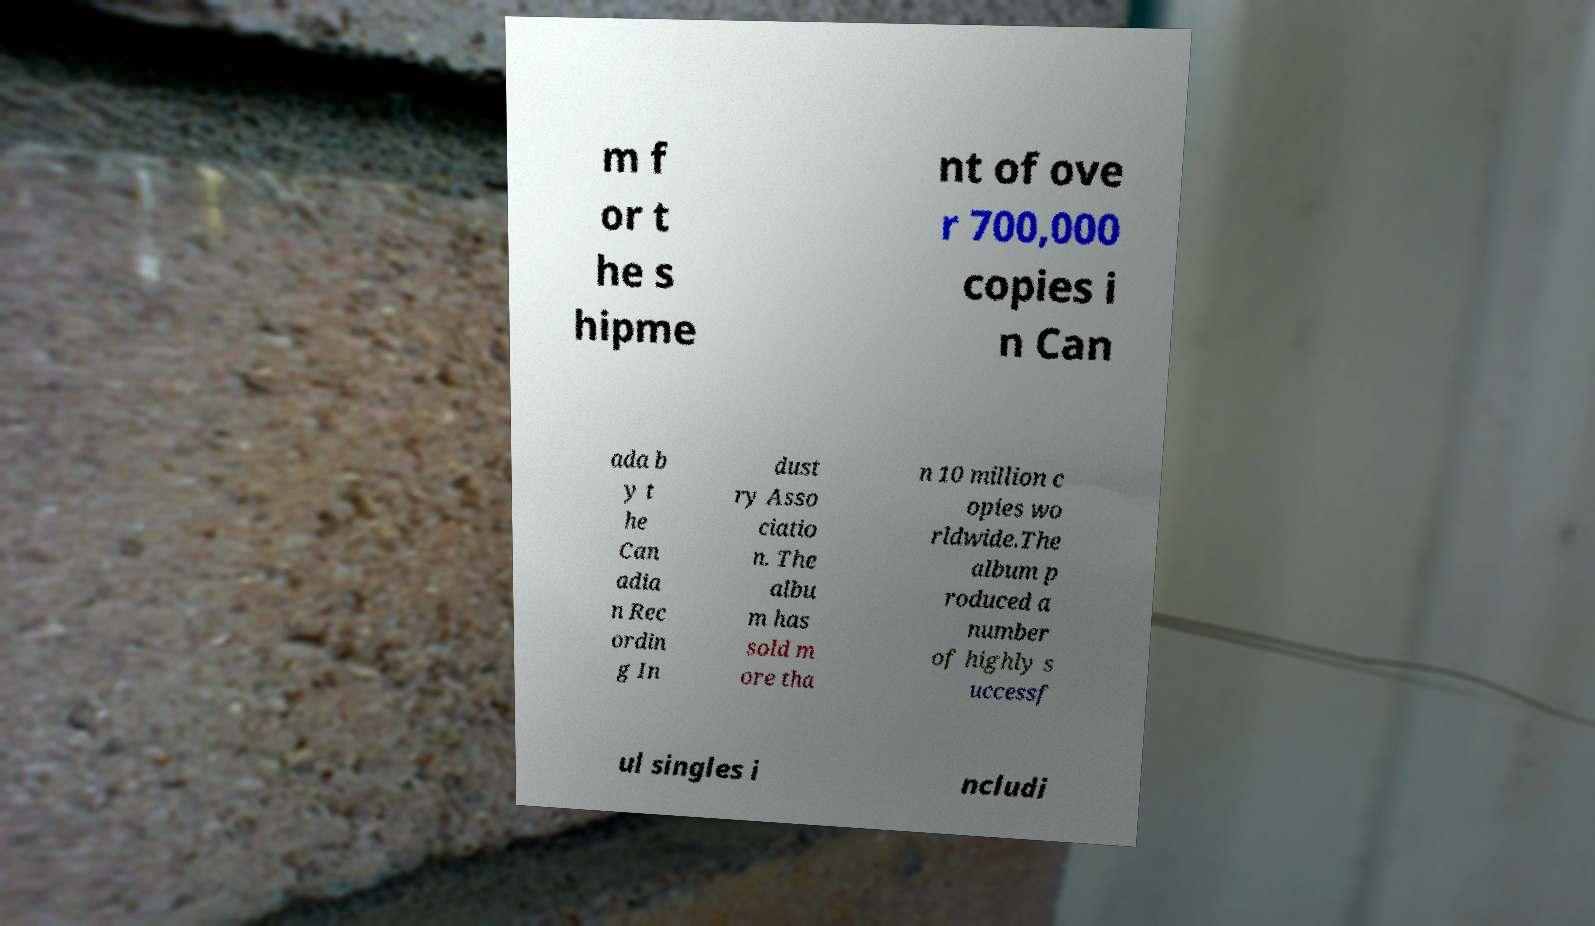Could you extract and type out the text from this image? m f or t he s hipme nt of ove r 700,000 copies i n Can ada b y t he Can adia n Rec ordin g In dust ry Asso ciatio n. The albu m has sold m ore tha n 10 million c opies wo rldwide.The album p roduced a number of highly s uccessf ul singles i ncludi 